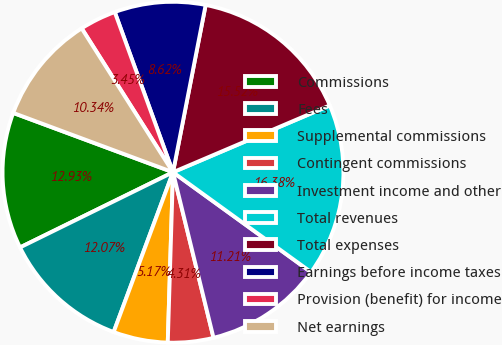Convert chart to OTSL. <chart><loc_0><loc_0><loc_500><loc_500><pie_chart><fcel>Commissions<fcel>Fees<fcel>Supplemental commissions<fcel>Contingent commissions<fcel>Investment income and other<fcel>Total revenues<fcel>Total expenses<fcel>Earnings before income taxes<fcel>Provision (benefit) for income<fcel>Net earnings<nl><fcel>12.93%<fcel>12.07%<fcel>5.17%<fcel>4.31%<fcel>11.21%<fcel>16.38%<fcel>15.52%<fcel>8.62%<fcel>3.45%<fcel>10.34%<nl></chart> 